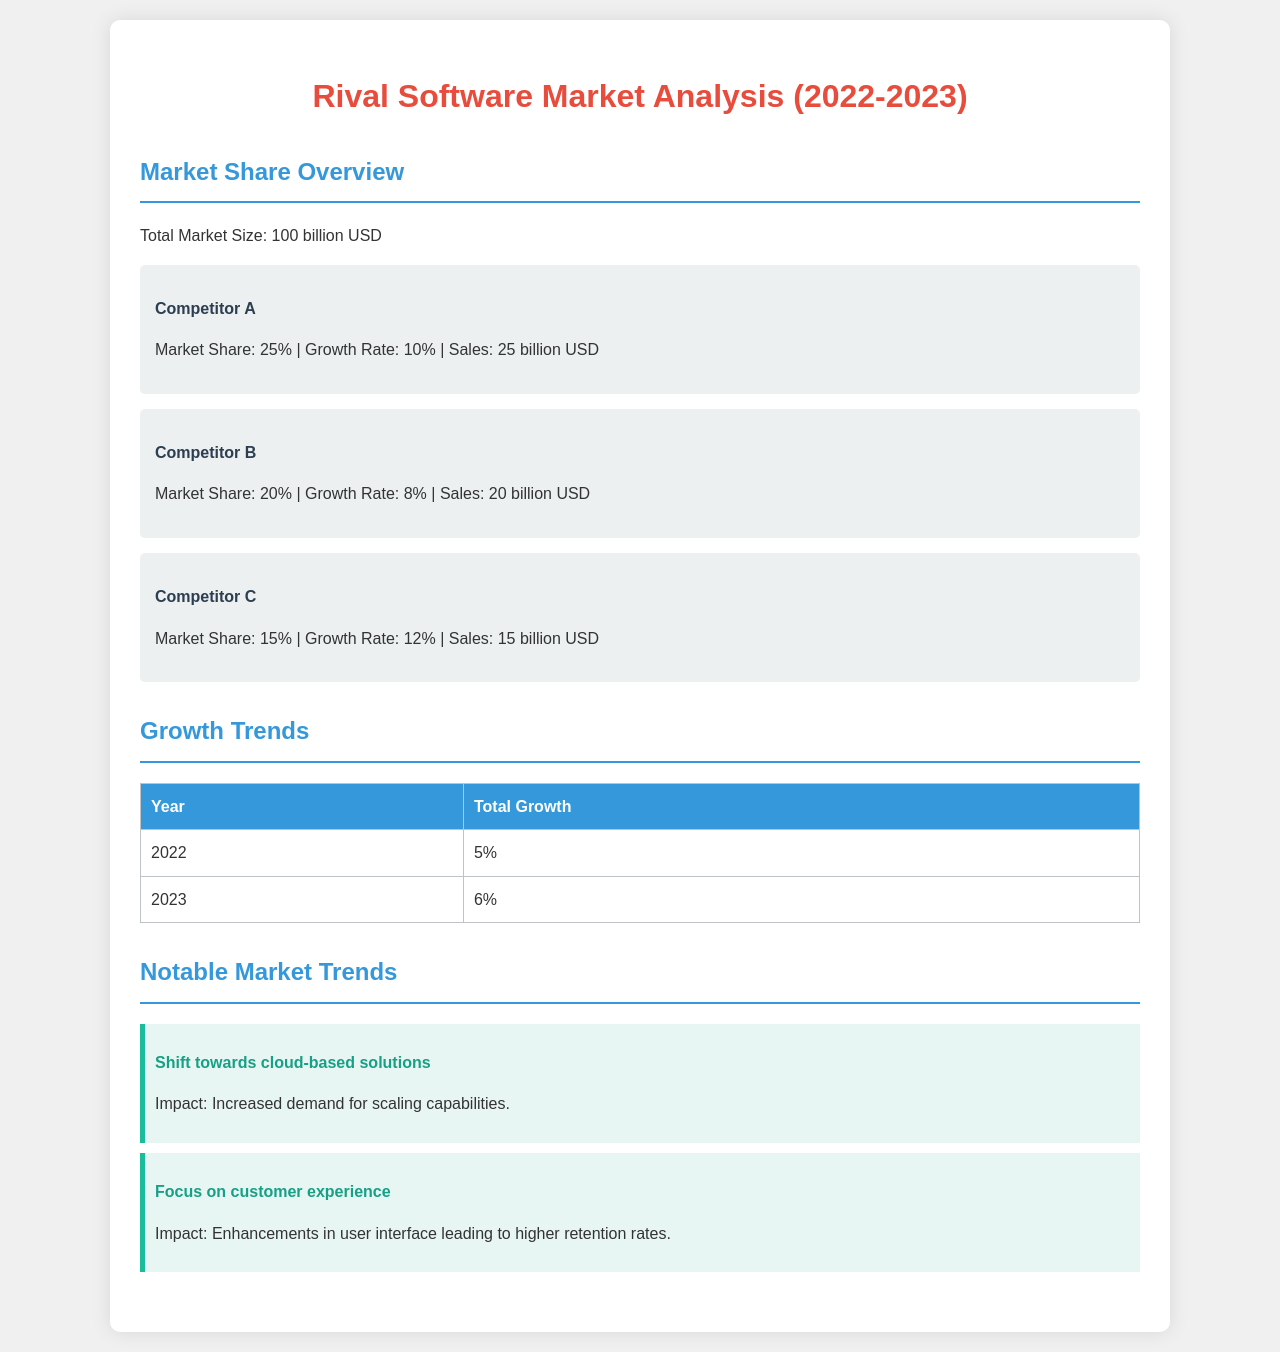What is the total market size? The total market size is explicitly mentioned in the document.
Answer: 100 billion USD What is Competitor A's market share? The document provides market share details for each competitor.
Answer: 25% What was the growth rate of Competitor C? The growth rates for each competitor are listed in the document.
Answer: 12% What is the total growth for the year 2023? The total growth figures for each year are outlined in the growth trends section.
Answer: 6% What notable market trend focuses on user interface? The document mentions notable trends affecting the market, one of which pertains to user interface.
Answer: Focus on customer experience Which competitor has the highest sales? The sales figures for each competitor are disclosed in the market share overview.
Answer: Competitor A What year shows a 5% total growth? The total growth figures for each year are provided in the table within the document.
Answer: 2022 What is the growth rate of Competitor B? Each competitor's growth rate is specified in the document.
Answer: 8% 